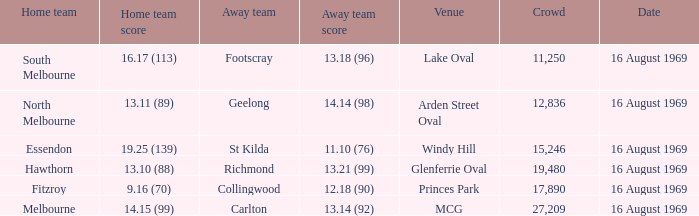When was the game played at Lake Oval? 16 August 1969. 